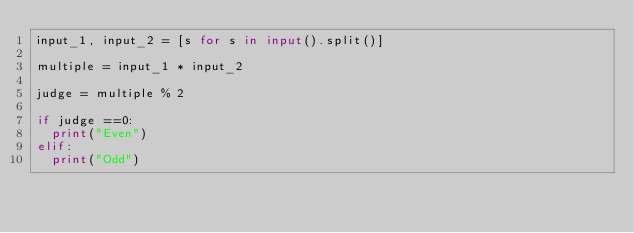<code> <loc_0><loc_0><loc_500><loc_500><_Python_>input_1, input_2 = [s for s in input().split()]

multiple = input_1 * input_2

judge = multiple % 2 

if judge ==0:
	print("Even")
elif:
	print("Odd")
  </code> 